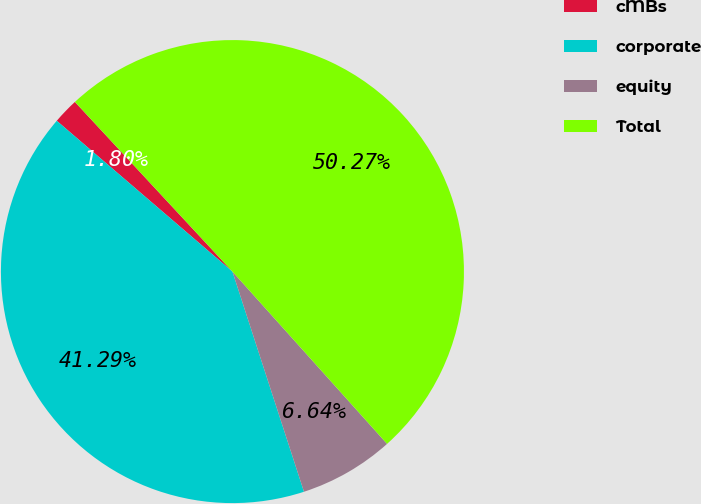<chart> <loc_0><loc_0><loc_500><loc_500><pie_chart><fcel>cMBs<fcel>corporate<fcel>equity<fcel>Total<nl><fcel>1.8%<fcel>41.29%<fcel>6.64%<fcel>50.27%<nl></chart> 